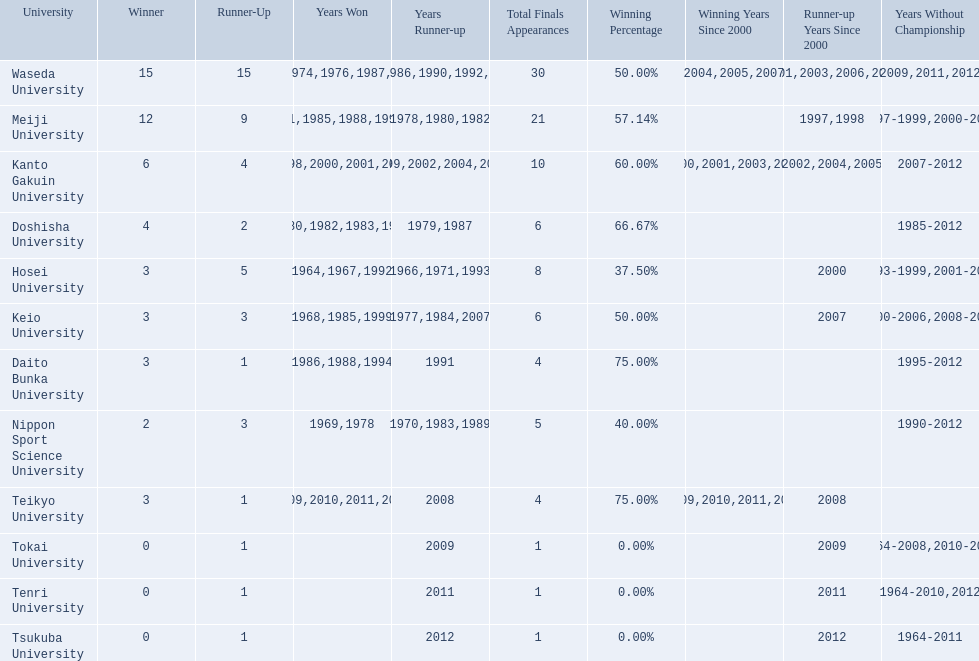What university were there in the all-japan university rugby championship? Waseda University, Meiji University, Kanto Gakuin University, Doshisha University, Hosei University, Keio University, Daito Bunka University, Nippon Sport Science University, Teikyo University, Tokai University, Tenri University, Tsukuba University. Of these who had more than 12 wins? Waseda University. 